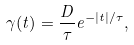<formula> <loc_0><loc_0><loc_500><loc_500>\gamma ( t ) = \frac { D } { \tau } e ^ { - | t | / \tau } ,</formula> 